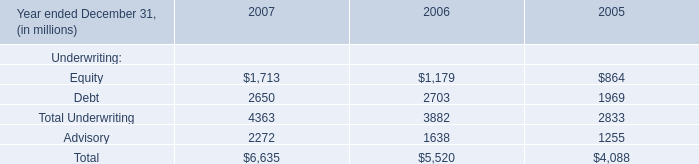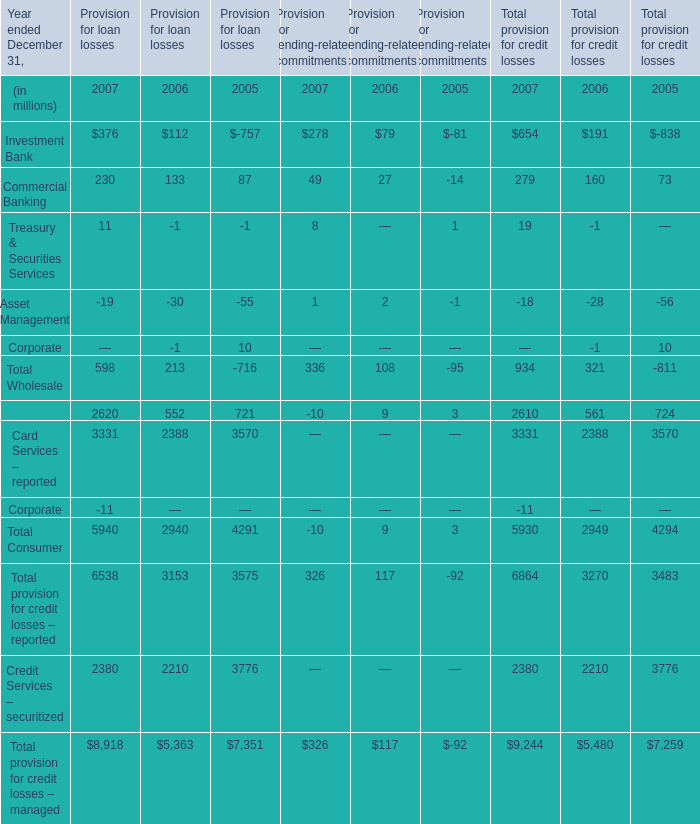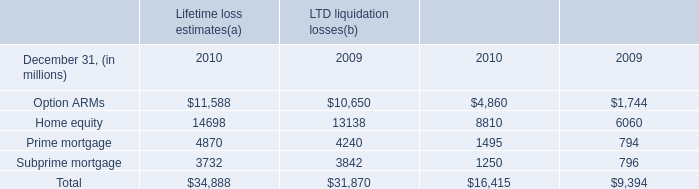What's the sum of Option ARMs of LTD liquidation losses 2010, Credit Services – securitized of Provision for loan losses 2006, and Card Services – reported of Total provision for credit losses 2006 ? 
Computations: ((4860.0 + 2210.0) + 2388.0)
Answer: 9458.0. 